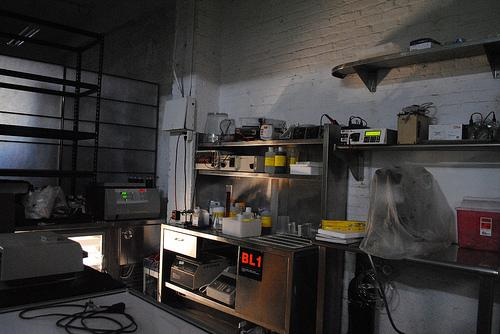What type of lighting can be observed in the image and mention their colors? There are red and green lights visible in the image. Explain the state of the black cord in the image and its location. The black cord is loose and unconnected, positioned on the floor. What dangerous object is in the image and what is its purpose? A medical waste disposal bin is present, used for proper disposal of hazardous materials. In the context of the image, what is the purpose of the white box on the shelf? The purpose of the white box on the shelf cannot be determined from the provided information. List three types of shelves or storage mentioned in the image information. 3. A black metal tier shelf Describe the surface or area where many items are placed. The items are placed on a stainless steel metal table. Identify the color and text on the sign located in the image. The sign is red and black and displays the text "bl1". What material is used for the paint on the brick wall, and describe its appearance? The paint is white and has a dingy appearance. How does the image make you feel? The image feels cluttered and disorganized. What text can be found in the image? BL1 in red bold text and two capital letters in orange What is the purpose of the red and green lights in the image? Cannot determine the purpose based on the given information. What are the contents of the white square container on the metal shelf? Cannot determine contents based on the given information. Can you point out the blue vase filled with colorful flowers located right next to the tan cardboard box on the shelf? They make a lovely contrast. No, it's not mentioned in the image. What type of shelf is at X:34 Y:26? A black metal tier shelf (X:34 Y:26 Width:94 Height:94) Detect any anomalies in the image. The loose black cord and the mysterious red box may be considered anomalies. Identify and describe the object at X:240 Y:240 A strange sign (X:230 Y:240 Width:50 Height:50) What is the relationship between the mysterious red box and the red and white object near it? They appear to be unrelated. What does the text at X:237 Y:248 say? Red letters and number (X:237 Y:248 Width:29 Height:29) Identify the type of waste disposal container in the image. Medical waste disposal bin Are there any objects on the floor in the image? Yes, a black cable on the floor. Analyze the interaction between the objects in the image. There are a few instances of object interaction, such as items resting on shelves or power cords connected to a machine. Is the white brick wall painted or not? Yes, it's painted white. Describe the object at X:376 Y:92. A tan cardboard box on a shelf (X:376 Y:92 Width:72 Height:72) Determine the color of the LED display on the device in the image. Green Is the black cord with no connection a potential safety hazard? Yes, it may pose a risk. Evaluate the overall quality of the image. The quality is fair, but it lacks focus and seems crowded. Describe the environment in the image. A room with various items such as bottles, boxes, a workstation, shelves, and signs with red and black or orange text. What color are the letters in the mysterious red box? Red Identify the object referred to as "a strange sign." Red and black bl1 sign (X:228 Y:238 Width:65 Height:65) 